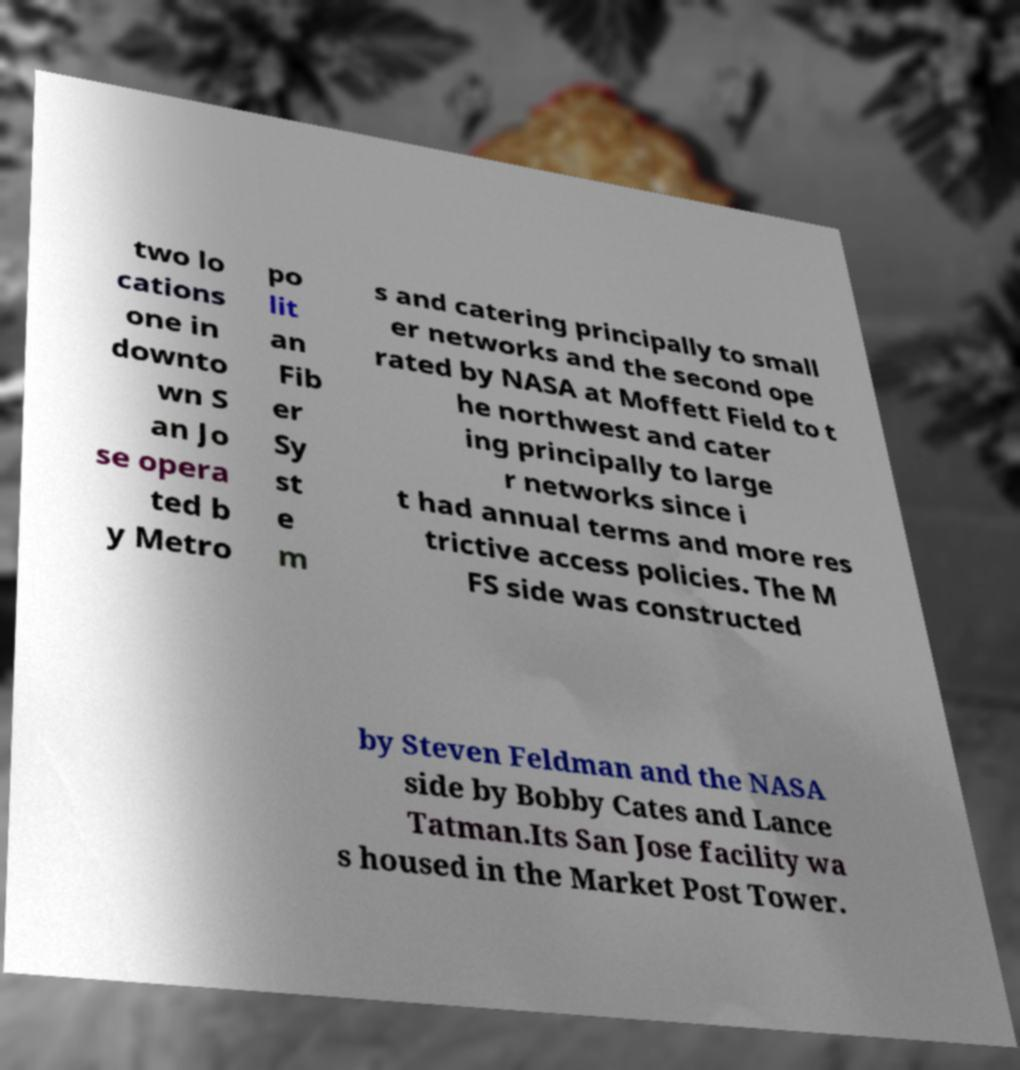What messages or text are displayed in this image? I need them in a readable, typed format. two lo cations one in downto wn S an Jo se opera ted b y Metro po lit an Fib er Sy st e m s and catering principally to small er networks and the second ope rated by NASA at Moffett Field to t he northwest and cater ing principally to large r networks since i t had annual terms and more res trictive access policies. The M FS side was constructed by Steven Feldman and the NASA side by Bobby Cates and Lance Tatman.Its San Jose facility wa s housed in the Market Post Tower. 